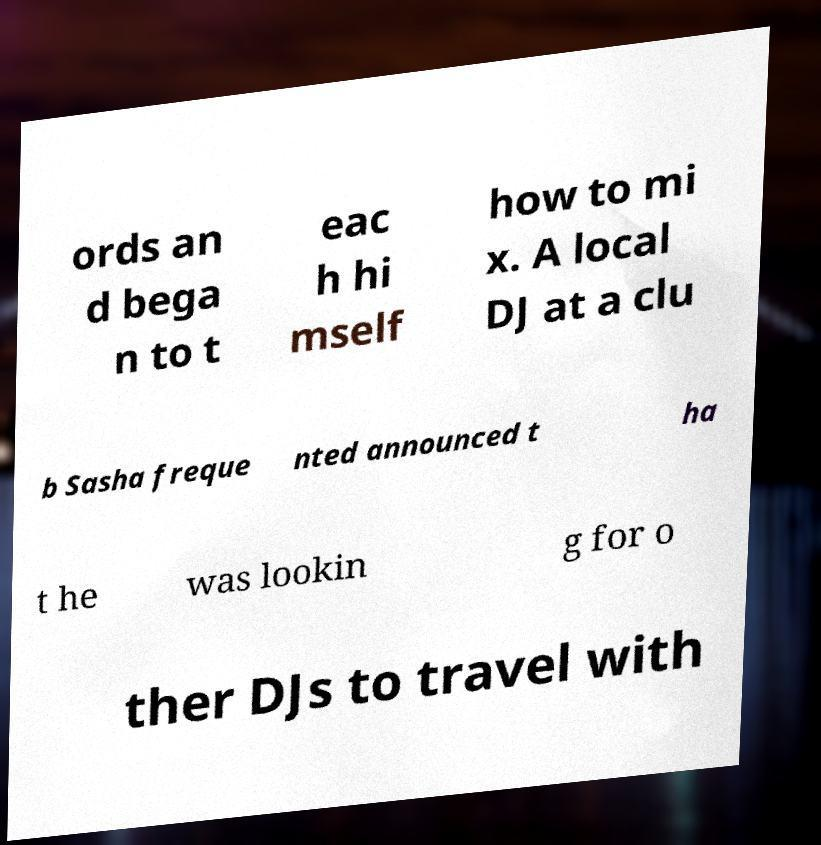Please read and relay the text visible in this image. What does it say? ords an d bega n to t eac h hi mself how to mi x. A local DJ at a clu b Sasha freque nted announced t ha t he was lookin g for o ther DJs to travel with 